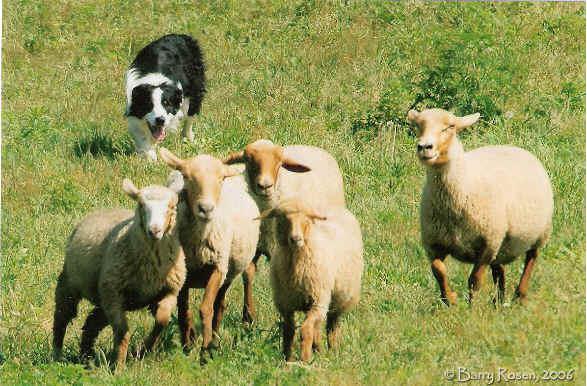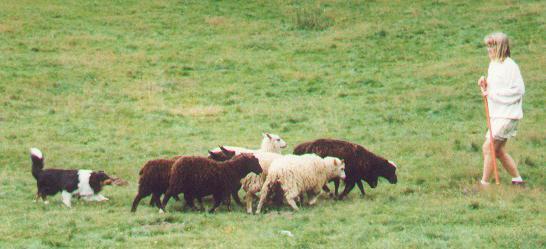The first image is the image on the left, the second image is the image on the right. Evaluate the accuracy of this statement regarding the images: "One image focuses on the dog close to one sheep.". Is it true? Answer yes or no. No. The first image is the image on the left, the second image is the image on the right. Examine the images to the left and right. Is the description "The dog in the image on the left is moving toward the camera." accurate? Answer yes or no. Yes. 